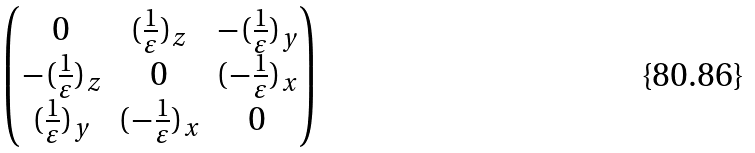Convert formula to latex. <formula><loc_0><loc_0><loc_500><loc_500>\begin{pmatrix} { 0 } & ( \frac { 1 } { \varepsilon } ) _ { z } & - ( \frac { 1 } { \varepsilon } ) _ { y } \\ { - ( \frac { 1 } { \varepsilon } ) _ { z } } & 0 & ( - \frac { 1 } { \varepsilon } ) _ { x } \\ { ( \frac { 1 } { \varepsilon } ) _ { y } } & ( - \frac { 1 } { \varepsilon } ) _ { x } & 0 \end{pmatrix}</formula> 